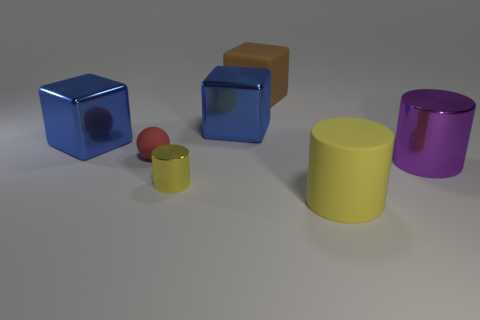Add 1 large cyan things. How many objects exist? 8 Subtract all spheres. How many objects are left? 6 Add 7 brown matte objects. How many brown matte objects are left? 8 Add 3 large blue blocks. How many large blue blocks exist? 5 Subtract 0 gray cylinders. How many objects are left? 7 Subtract all tiny purple blocks. Subtract all large brown rubber blocks. How many objects are left? 6 